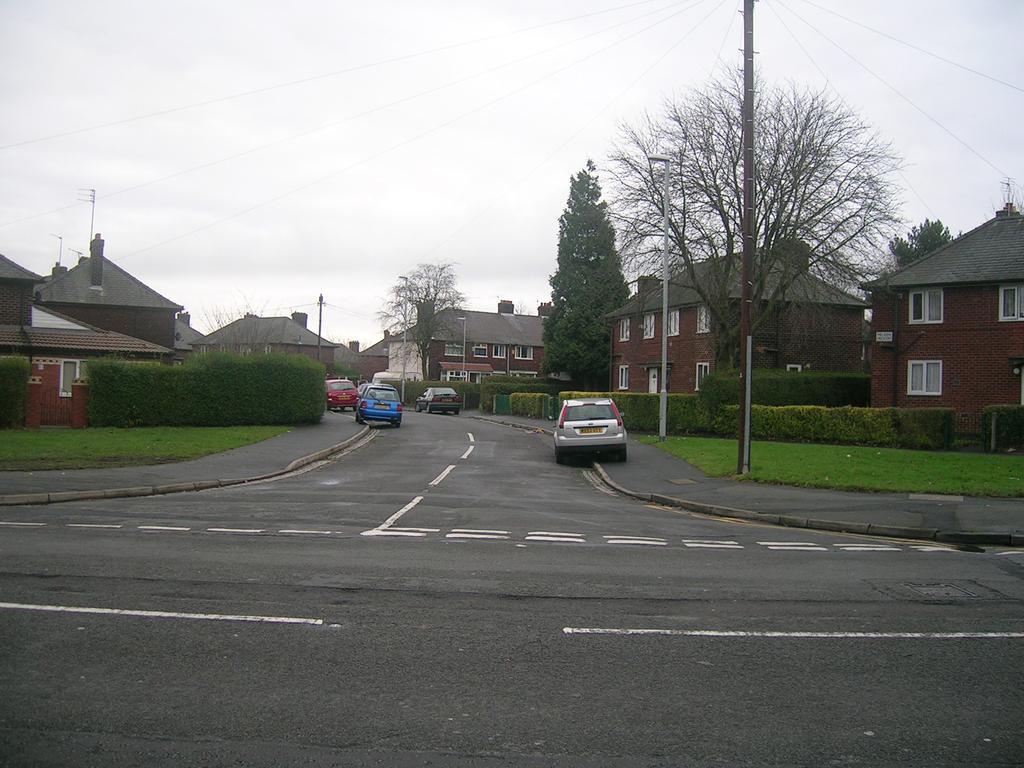In one or two sentences, can you explain what this image depicts? In the middle of the image we can see some vehicles on the road. Behind the vehicles we can see some plants, trees, poles and buildings. At the top of the image we can see some clouds in the sky. 